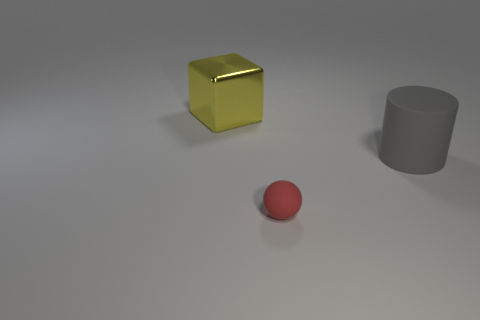Are there any objects in front of the big object left of the tiny red matte object? Yes, there is a cylindrical grey object situated in front of the large yellow cube, which itself is positioned to the left of the small red sphere. 